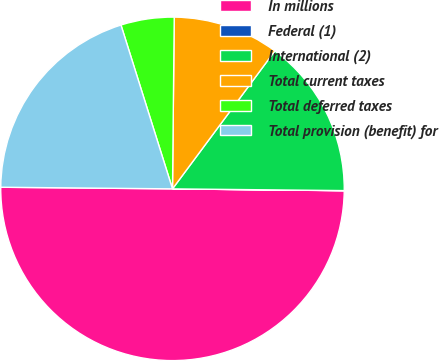Convert chart. <chart><loc_0><loc_0><loc_500><loc_500><pie_chart><fcel>In millions<fcel>Federal (1)<fcel>International (2)<fcel>Total current taxes<fcel>Total deferred taxes<fcel>Total provision (benefit) for<nl><fcel>49.98%<fcel>0.01%<fcel>15.0%<fcel>10.0%<fcel>5.01%<fcel>20.0%<nl></chart> 